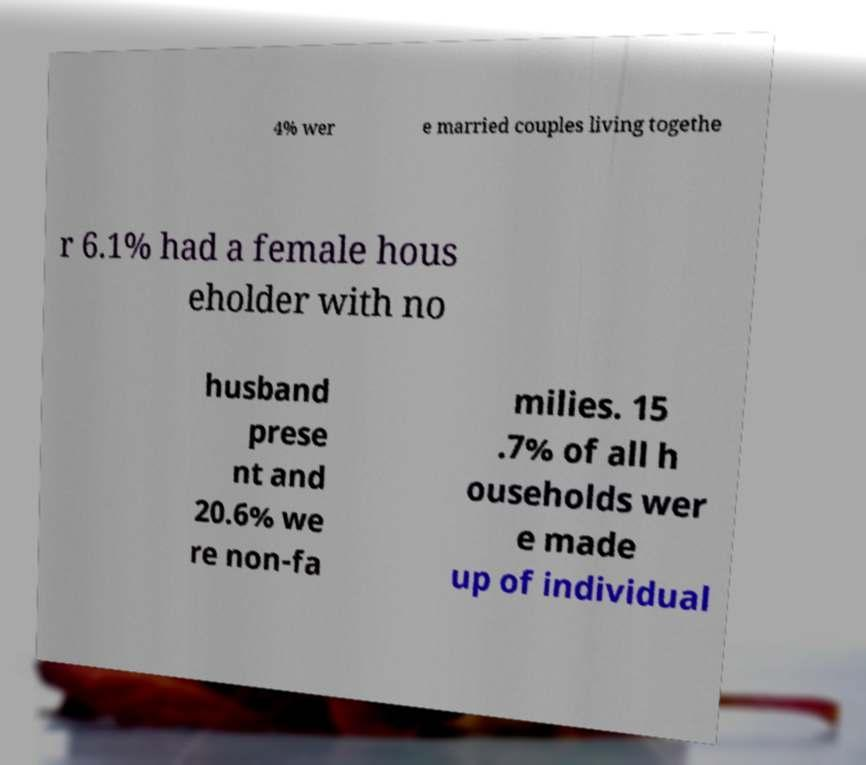Could you extract and type out the text from this image? 4% wer e married couples living togethe r 6.1% had a female hous eholder with no husband prese nt and 20.6% we re non-fa milies. 15 .7% of all h ouseholds wer e made up of individual 